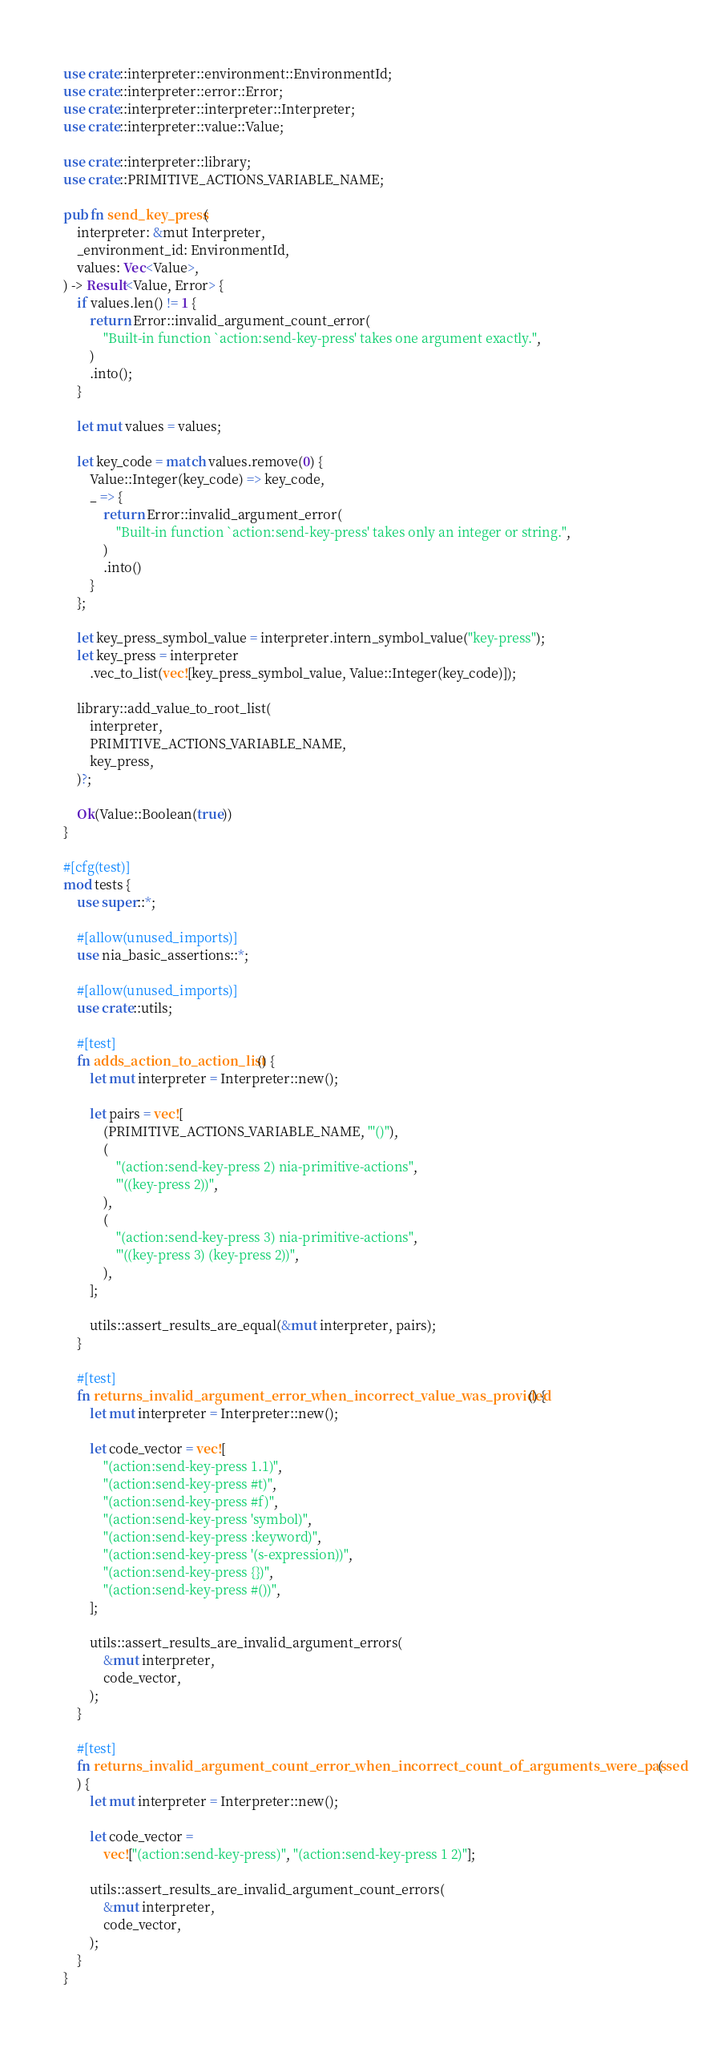<code> <loc_0><loc_0><loc_500><loc_500><_Rust_>use crate::interpreter::environment::EnvironmentId;
use crate::interpreter::error::Error;
use crate::interpreter::interpreter::Interpreter;
use crate::interpreter::value::Value;

use crate::interpreter::library;
use crate::PRIMITIVE_ACTIONS_VARIABLE_NAME;

pub fn send_key_press(
    interpreter: &mut Interpreter,
    _environment_id: EnvironmentId,
    values: Vec<Value>,
) -> Result<Value, Error> {
    if values.len() != 1 {
        return Error::invalid_argument_count_error(
            "Built-in function `action:send-key-press' takes one argument exactly.",
        )
        .into();
    }

    let mut values = values;

    let key_code = match values.remove(0) {
        Value::Integer(key_code) => key_code,
        _ => {
            return Error::invalid_argument_error(
                "Built-in function `action:send-key-press' takes only an integer or string.",
            )
            .into()
        }
    };

    let key_press_symbol_value = interpreter.intern_symbol_value("key-press");
    let key_press = interpreter
        .vec_to_list(vec![key_press_symbol_value, Value::Integer(key_code)]);

    library::add_value_to_root_list(
        interpreter,
        PRIMITIVE_ACTIONS_VARIABLE_NAME,
        key_press,
    )?;

    Ok(Value::Boolean(true))
}

#[cfg(test)]
mod tests {
    use super::*;

    #[allow(unused_imports)]
    use nia_basic_assertions::*;

    #[allow(unused_imports)]
    use crate::utils;

    #[test]
    fn adds_action_to_action_list() {
        let mut interpreter = Interpreter::new();

        let pairs = vec![
            (PRIMITIVE_ACTIONS_VARIABLE_NAME, "'()"),
            (
                "(action:send-key-press 2) nia-primitive-actions",
                "'((key-press 2))",
            ),
            (
                "(action:send-key-press 3) nia-primitive-actions",
                "'((key-press 3) (key-press 2))",
            ),
        ];

        utils::assert_results_are_equal(&mut interpreter, pairs);
    }

    #[test]
    fn returns_invalid_argument_error_when_incorrect_value_was_provided() {
        let mut interpreter = Interpreter::new();

        let code_vector = vec![
            "(action:send-key-press 1.1)",
            "(action:send-key-press #t)",
            "(action:send-key-press #f)",
            "(action:send-key-press 'symbol)",
            "(action:send-key-press :keyword)",
            "(action:send-key-press '(s-expression))",
            "(action:send-key-press {})",
            "(action:send-key-press #())",
        ];

        utils::assert_results_are_invalid_argument_errors(
            &mut interpreter,
            code_vector,
        );
    }

    #[test]
    fn returns_invalid_argument_count_error_when_incorrect_count_of_arguments_were_passed(
    ) {
        let mut interpreter = Interpreter::new();

        let code_vector =
            vec!["(action:send-key-press)", "(action:send-key-press 1 2)"];

        utils::assert_results_are_invalid_argument_count_errors(
            &mut interpreter,
            code_vector,
        );
    }
}
</code> 